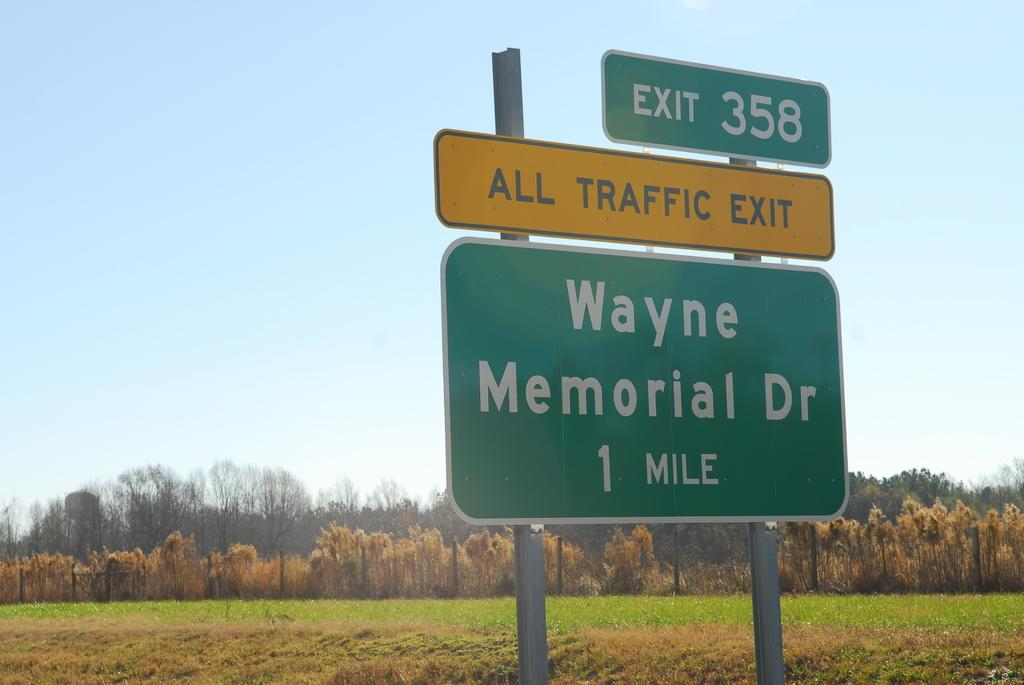Provide a one-sentence caption for the provided image. A green sign marking the exit 358 and Wayne Memorial dr. 